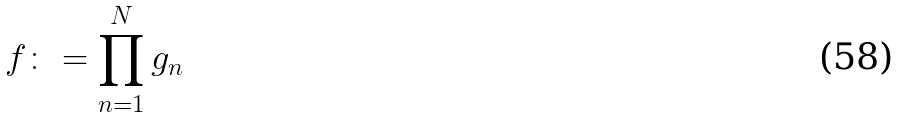<formula> <loc_0><loc_0><loc_500><loc_500>f \colon = \prod _ { n = 1 } ^ { N } g _ { n }</formula> 